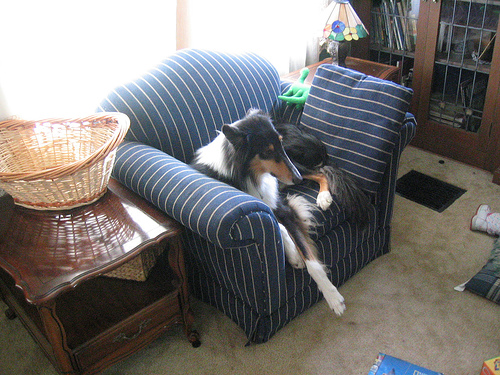<image>
Can you confirm if the basket is next to the dog? Yes. The basket is positioned adjacent to the dog, located nearby in the same general area. Where is the collie in relation to the chair? Is it on the chair? Yes. Looking at the image, I can see the collie is positioned on top of the chair, with the chair providing support. Is the dog to the right of the table? Yes. From this viewpoint, the dog is positioned to the right side relative to the table. 